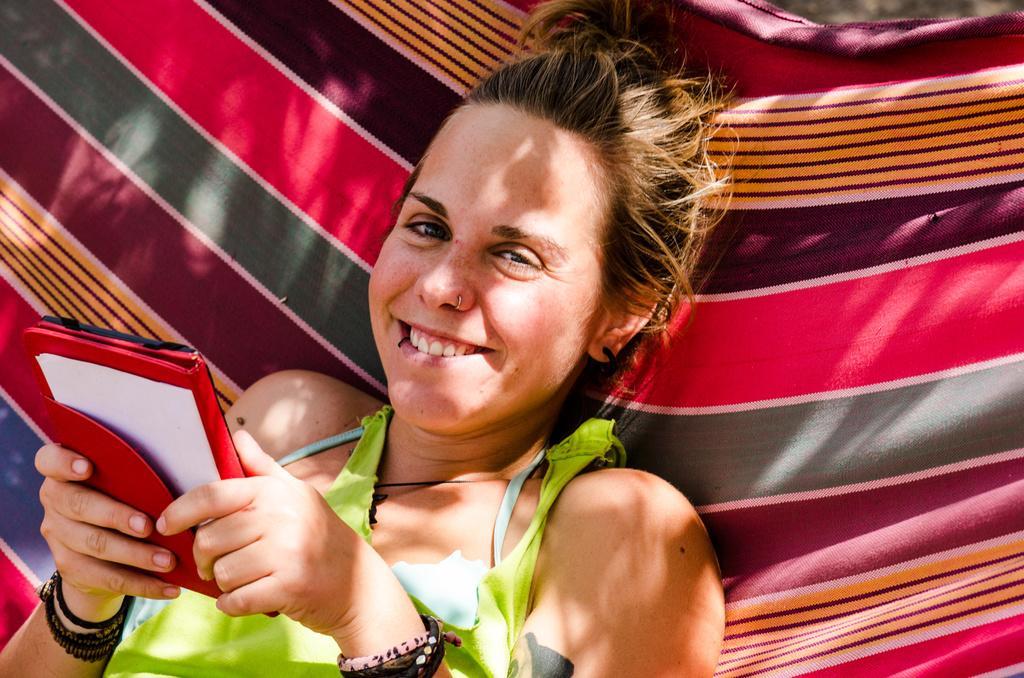Can you describe this image briefly? A woman is lying and smiling holding an object. She is wearing a green dress. 